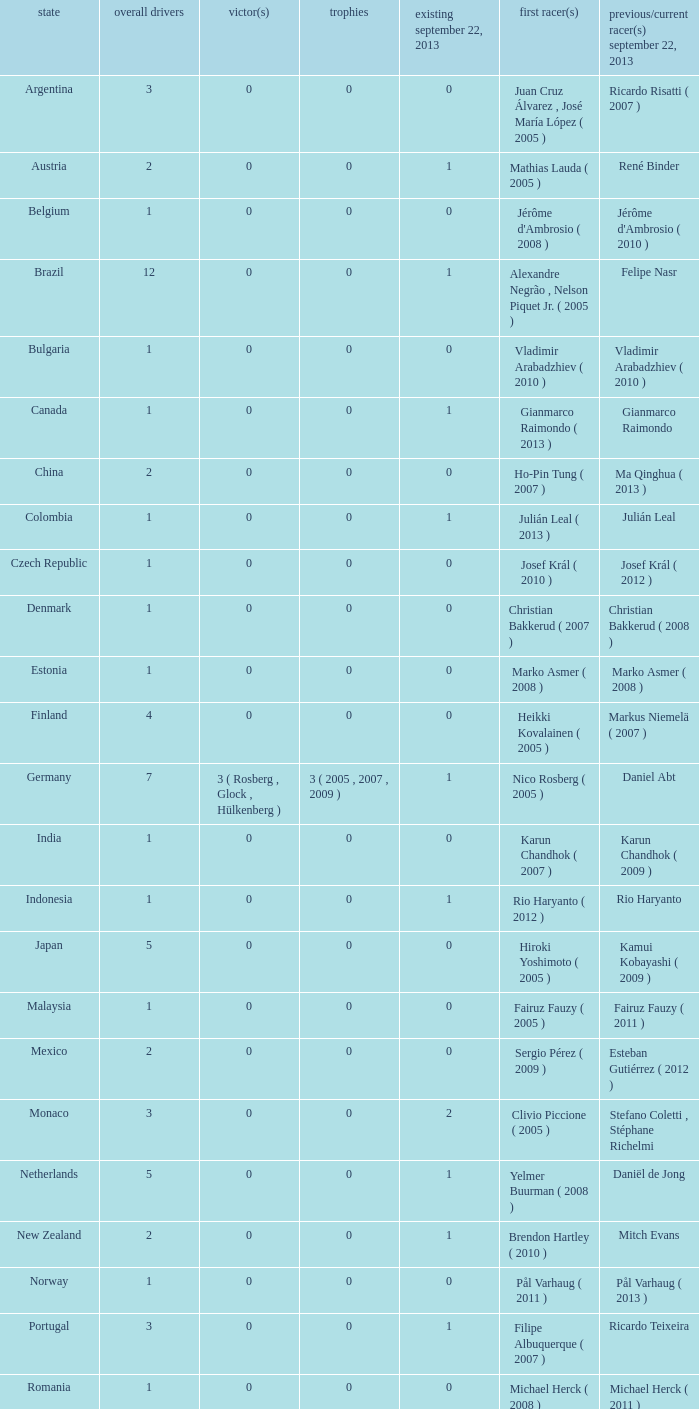Can you give me this table as a dict? {'header': ['state', 'overall drivers', 'victor(s)', 'trophies', 'existing september 22, 2013', 'first racer(s)', 'previous/current racer(s) september 22, 2013'], 'rows': [['Argentina', '3', '0', '0', '0', 'Juan Cruz Álvarez , José María López ( 2005 )', 'Ricardo Risatti ( 2007 )'], ['Austria', '2', '0', '0', '1', 'Mathias Lauda ( 2005 )', 'René Binder'], ['Belgium', '1', '0', '0', '0', "Jérôme d'Ambrosio ( 2008 )", "Jérôme d'Ambrosio ( 2010 )"], ['Brazil', '12', '0', '0', '1', 'Alexandre Negrão , Nelson Piquet Jr. ( 2005 )', 'Felipe Nasr'], ['Bulgaria', '1', '0', '0', '0', 'Vladimir Arabadzhiev ( 2010 )', 'Vladimir Arabadzhiev ( 2010 )'], ['Canada', '1', '0', '0', '1', 'Gianmarco Raimondo ( 2013 )', 'Gianmarco Raimondo'], ['China', '2', '0', '0', '0', 'Ho-Pin Tung ( 2007 )', 'Ma Qinghua ( 2013 )'], ['Colombia', '1', '0', '0', '1', 'Julián Leal ( 2013 )', 'Julián Leal'], ['Czech Republic', '1', '0', '0', '0', 'Josef Král ( 2010 )', 'Josef Král ( 2012 )'], ['Denmark', '1', '0', '0', '0', 'Christian Bakkerud ( 2007 )', 'Christian Bakkerud ( 2008 )'], ['Estonia', '1', '0', '0', '0', 'Marko Asmer ( 2008 )', 'Marko Asmer ( 2008 )'], ['Finland', '4', '0', '0', '0', 'Heikki Kovalainen ( 2005 )', 'Markus Niemelä ( 2007 )'], ['Germany', '7', '3 ( Rosberg , Glock , Hülkenberg )', '3 ( 2005 , 2007 , 2009 )', '1', 'Nico Rosberg ( 2005 )', 'Daniel Abt'], ['India', '1', '0', '0', '0', 'Karun Chandhok ( 2007 )', 'Karun Chandhok ( 2009 )'], ['Indonesia', '1', '0', '0', '1', 'Rio Haryanto ( 2012 )', 'Rio Haryanto'], ['Japan', '5', '0', '0', '0', 'Hiroki Yoshimoto ( 2005 )', 'Kamui Kobayashi ( 2009 )'], ['Malaysia', '1', '0', '0', '0', 'Fairuz Fauzy ( 2005 )', 'Fairuz Fauzy ( 2011 )'], ['Mexico', '2', '0', '0', '0', 'Sergio Pérez ( 2009 )', 'Esteban Gutiérrez ( 2012 )'], ['Monaco', '3', '0', '0', '2', 'Clivio Piccione ( 2005 )', 'Stefano Coletti , Stéphane Richelmi'], ['Netherlands', '5', '0', '0', '1', 'Yelmer Buurman ( 2008 )', 'Daniël de Jong'], ['New Zealand', '2', '0', '0', '1', 'Brendon Hartley ( 2010 )', 'Mitch Evans'], ['Norway', '1', '0', '0', '0', 'Pål Varhaug ( 2011 )', 'Pål Varhaug ( 2013 )'], ['Portugal', '3', '0', '0', '1', 'Filipe Albuquerque ( 2007 )', 'Ricardo Teixeira'], ['Romania', '1', '0', '0', '0', 'Michael Herck ( 2008 )', 'Michael Herck ( 2011 )'], ['Russia', '2', '0', '0', '0', 'Vitaly Petrov ( 2006 )', 'Mikhail Aleshin ( 2011 )'], ['Serbia', '1', '0', '0', '0', 'Miloš Pavlović ( 2008 )', 'Miloš Pavlović ( 2008 )'], ['South Africa', '1', '0', '0', '0', 'Adrian Zaugg ( 2007 )', 'Adrian Zaugg ( 2010 )'], ['Spain', '10', '0', '0', '2', 'Borja García , Sergio Hernández ( 2005 )', 'Sergio Canamasas , Dani Clos'], ['Sweden', '1', '0', '0', '1', 'Marcus Ericsson ( 2010 )', 'Marcus Ericsson'], ['Switzerland', '5', '0', '0', '2', 'Neel Jani ( 2005 )', 'Fabio Leimer , Simon Trummer'], ['Turkey', '2', '0', '0', '0', 'Can Artam ( 2005 )', 'Jason Tahincioglu ( 2007 )'], ['United Arab Emirates', '1', '0', '0', '0', 'Andreas Zuber ( 2006 )', 'Andreas Zuber ( 2009 )'], ['United States', '4', '0', '0', '2', 'Scott Speed ( 2005 )', 'Jake Rosenzweig , Alexander Rossi']]} How many champions were there when the last driver was Gianmarco Raimondo? 0.0. 